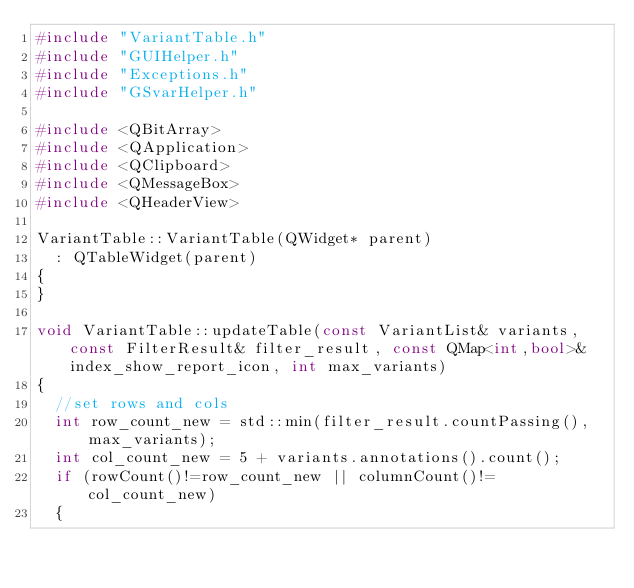<code> <loc_0><loc_0><loc_500><loc_500><_C++_>#include "VariantTable.h"
#include "GUIHelper.h"
#include "Exceptions.h"
#include "GSvarHelper.h"

#include <QBitArray>
#include <QApplication>
#include <QClipboard>
#include <QMessageBox>
#include <QHeaderView>

VariantTable::VariantTable(QWidget* parent)
	: QTableWidget(parent)
{
}

void VariantTable::updateTable(const VariantList& variants, const FilterResult& filter_result, const QMap<int,bool>& index_show_report_icon, int max_variants)
{
	//set rows and cols
	int row_count_new = std::min(filter_result.countPassing(), max_variants);
	int col_count_new = 5 + variants.annotations().count();
	if (rowCount()!=row_count_new || columnCount()!=col_count_new)
	{</code> 